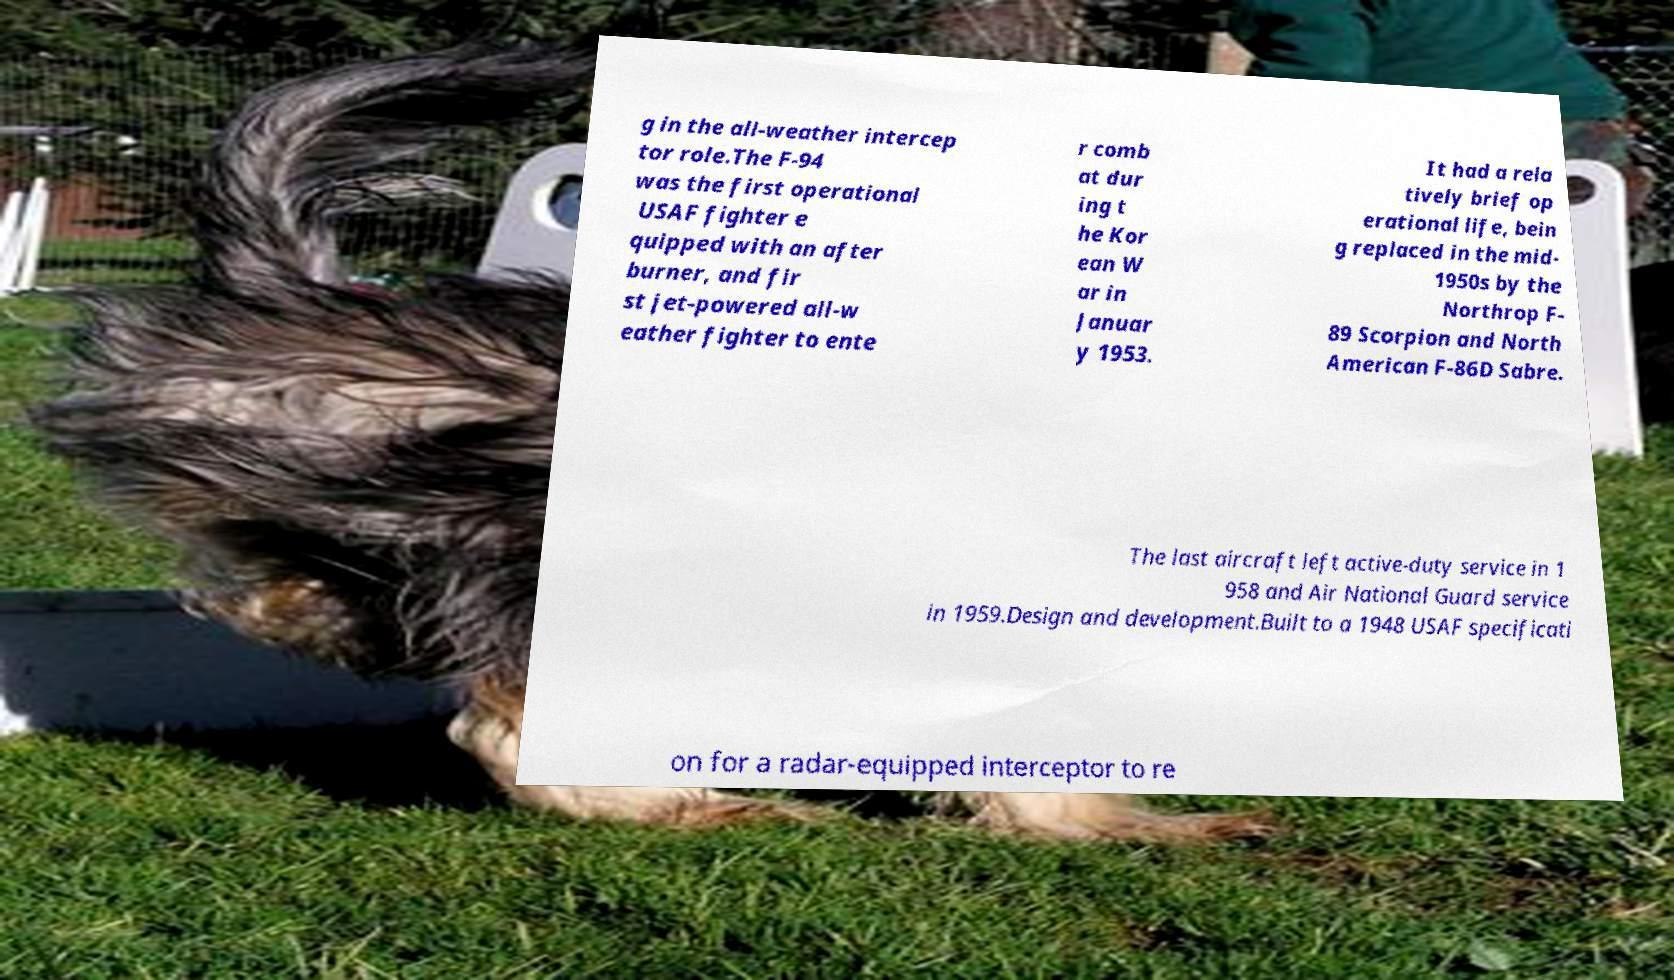For documentation purposes, I need the text within this image transcribed. Could you provide that? g in the all-weather intercep tor role.The F-94 was the first operational USAF fighter e quipped with an after burner, and fir st jet-powered all-w eather fighter to ente r comb at dur ing t he Kor ean W ar in Januar y 1953. It had a rela tively brief op erational life, bein g replaced in the mid- 1950s by the Northrop F- 89 Scorpion and North American F-86D Sabre. The last aircraft left active-duty service in 1 958 and Air National Guard service in 1959.Design and development.Built to a 1948 USAF specificati on for a radar-equipped interceptor to re 